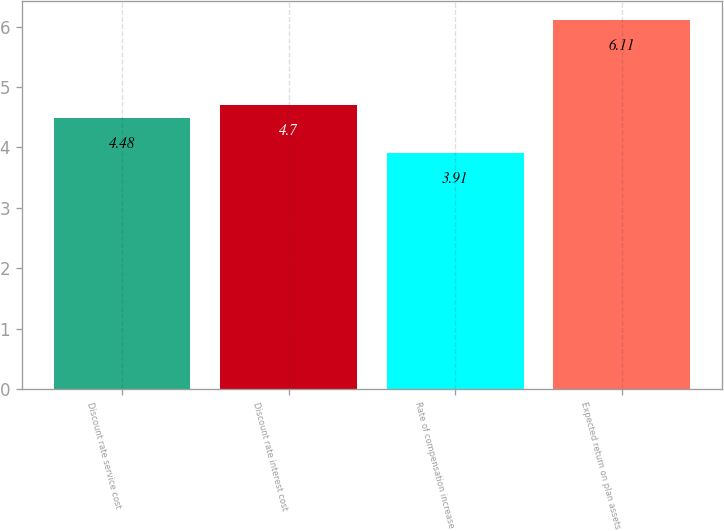Convert chart to OTSL. <chart><loc_0><loc_0><loc_500><loc_500><bar_chart><fcel>Discount rate service cost<fcel>Discount rate interest cost<fcel>Rate of compensation increase<fcel>Expected return on plan assets<nl><fcel>4.48<fcel>4.7<fcel>3.91<fcel>6.11<nl></chart> 